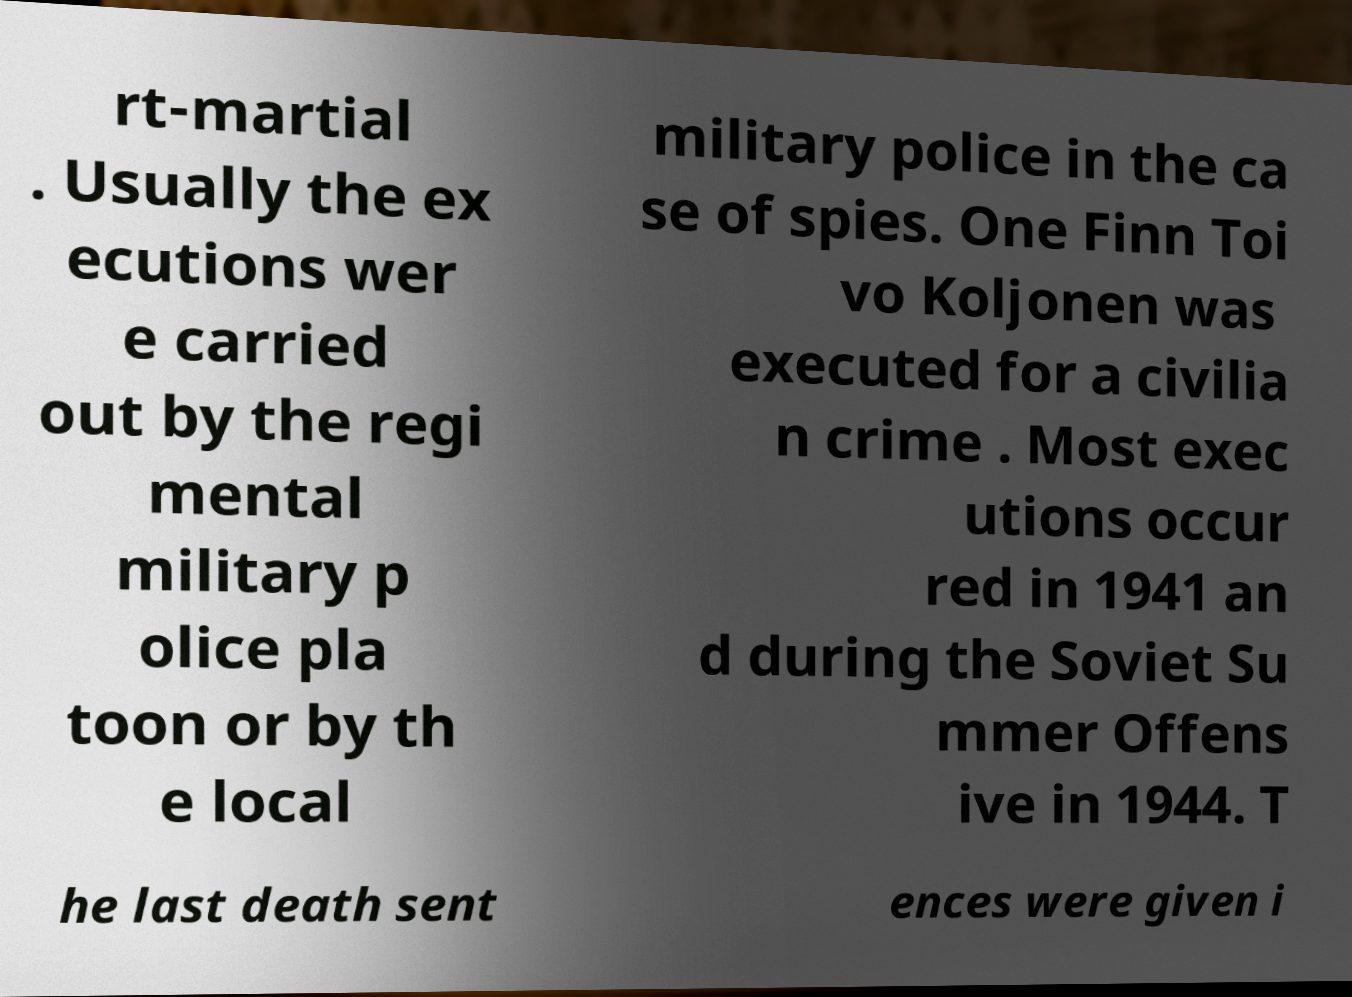For documentation purposes, I need the text within this image transcribed. Could you provide that? rt-martial . Usually the ex ecutions wer e carried out by the regi mental military p olice pla toon or by th e local military police in the ca se of spies. One Finn Toi vo Koljonen was executed for a civilia n crime . Most exec utions occur red in 1941 an d during the Soviet Su mmer Offens ive in 1944. T he last death sent ences were given i 